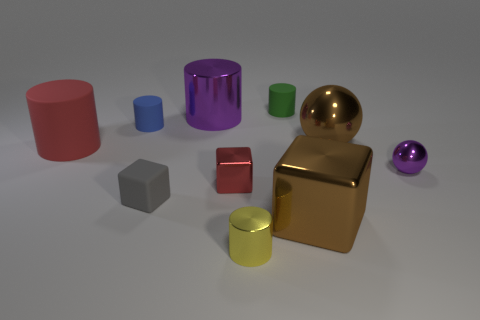Subtract all green cylinders. How many cylinders are left? 4 Subtract all blue cylinders. How many cylinders are left? 4 Subtract all brown cylinders. Subtract all blue cubes. How many cylinders are left? 5 Subtract all cubes. How many objects are left? 7 Subtract 0 green balls. How many objects are left? 10 Subtract all big brown metal things. Subtract all small shiny cylinders. How many objects are left? 7 Add 5 red things. How many red things are left? 7 Add 5 tiny green cylinders. How many tiny green cylinders exist? 6 